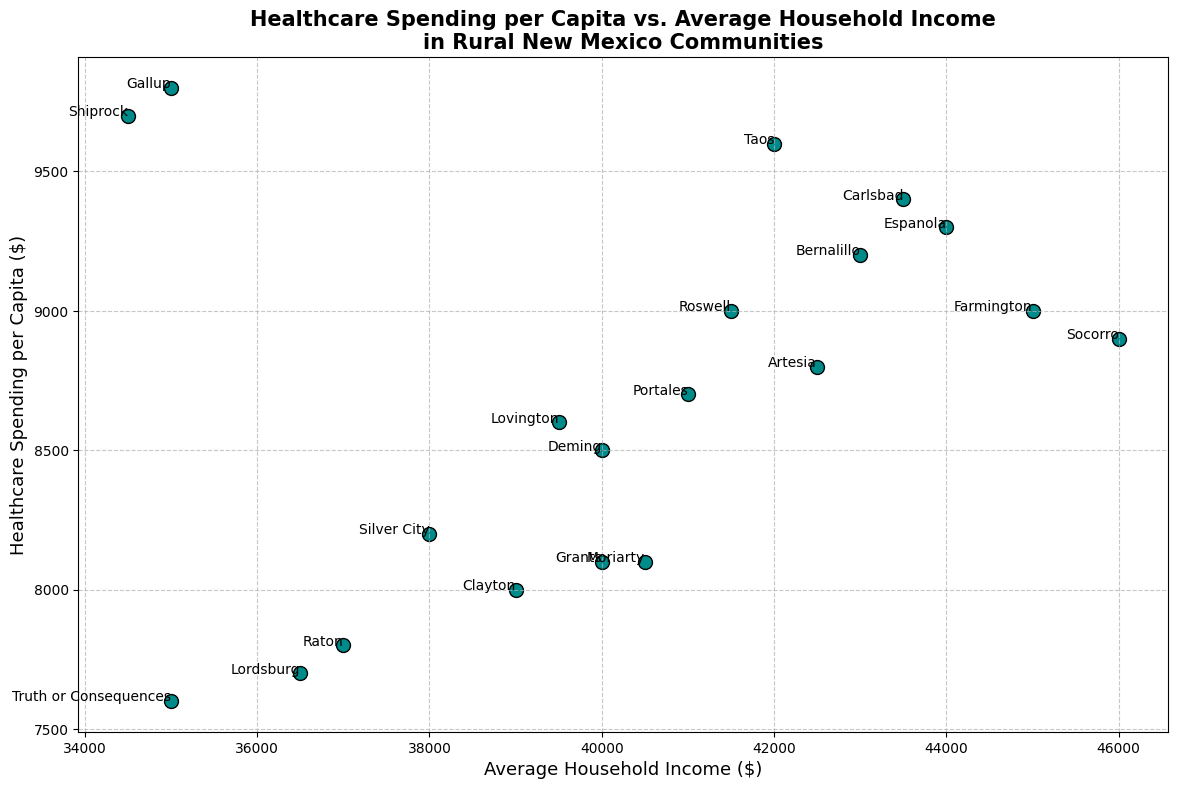Which community has the highest healthcare spending per capita? The community with the highest point on the vertical axis represents the highest healthcare spending per capita. Observing the scatter plot, Gallup is positioned at the topmost point, corresponding to a healthcare spending per capita of $9800.
Answer: Gallup What is the difference in healthcare spending per capita between Gallup and Raton? According to the figure, Gallup's healthcare spending per capita is $9800, and Raton's is $7800. The difference is calculated by subtracting Raton's spending from Gallup's: $9800 - $7800 = $2000.
Answer: $2000 Which community has the lowest average household income and what is its healthcare spending per capita? The lowest point on the horizontal axis represents the lowest average household income. Identifying this point, Shiprock has the lowest average household income of $34500, with a healthcare spending per capita of $9700.
Answer: Shiprock, $9700 Are there any communities with the same average household income but different healthcare spending per capita? By closely examining the scatter plot, we observe that Gallup and Truth or Consequences both have an average household income of $35000, but their healthcare spending per capita differs, with Gallup at $9800 and Truth or Consequences at $7600.
Answer: Yes, Gallup and Truth or Consequences Does a higher average household income coincide with higher healthcare spending per capita in rural New Mexico communities? To determine this, we observe the general trend in the scatter plot. While there are cases like Gallup and Shiprock with high healthcare spending and lower-income, the overall scatter doesn't show a clear upward trend aligning higher income with higher spending. Therefore, we conclude that higher average household income does not consistently coincide with higher healthcare spending per capita.
Answer: No Which community has the second-highest healthcare spending per capita and what is its average household income? Noting the second highest point on the vertical axis, Shiprock has the second-highest healthcare spending per capita at $9700. The average household income for Shiprock is $34500.
Answer: Shiprock, $34500 Which community has the closest healthcare spending per capita to the average household income of 40000? Locate the data points that align closest to a horizontal value of $40000 as average household income. Clayton, Deming, and Grants are all close to this range. Among these, Deming has the closest healthcare spending per capita at $8500.
Answer: Deming What is the average healthcare spending per capita for communities with an average household income above $42000? First, identify communities with an average household income above $42000: Artesia, Bernalillo, Carlsbad, Espanola, Farmington, and Socorro. Adding their respective healthcare spending per capita: $8800 + $9200 + $9400 + $9300 + $9000 + $8900 = $54600. Average is $54600/6 = $9100.
Answer: $9100 